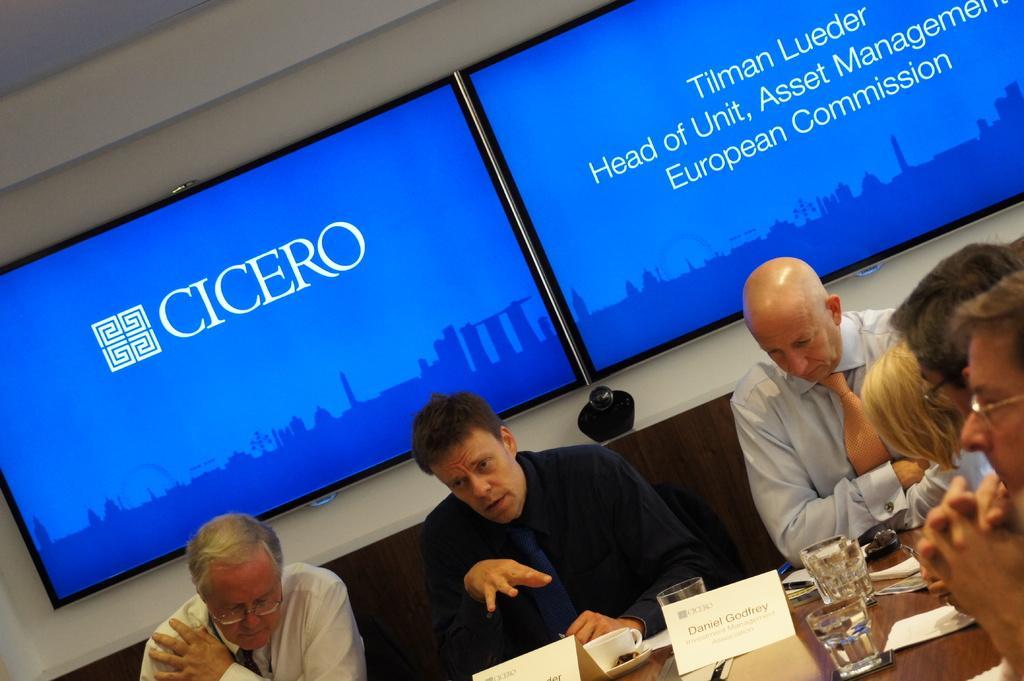Could you give a brief overview of what you see in this image? In this image we can see few people. There are few objects on the table. There are few televisions on the wall. We can see some text and few animated objects on the screen. 